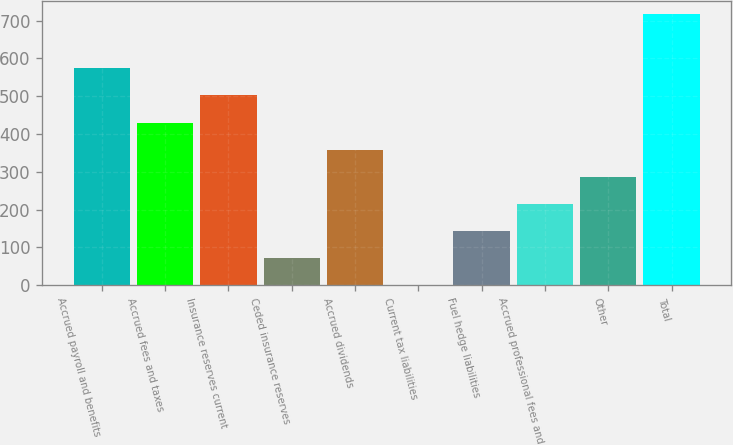Convert chart to OTSL. <chart><loc_0><loc_0><loc_500><loc_500><bar_chart><fcel>Accrued payroll and benefits<fcel>Accrued fees and taxes<fcel>Insurance reserves current<fcel>Ceded insurance reserves<fcel>Accrued dividends<fcel>Current tax liabilities<fcel>Fuel hedge liabilities<fcel>Accrued professional fees and<fcel>Other<fcel>Total<nl><fcel>573.38<fcel>430.16<fcel>501.77<fcel>72.11<fcel>358.55<fcel>0.5<fcel>143.72<fcel>215.33<fcel>286.94<fcel>716.6<nl></chart> 